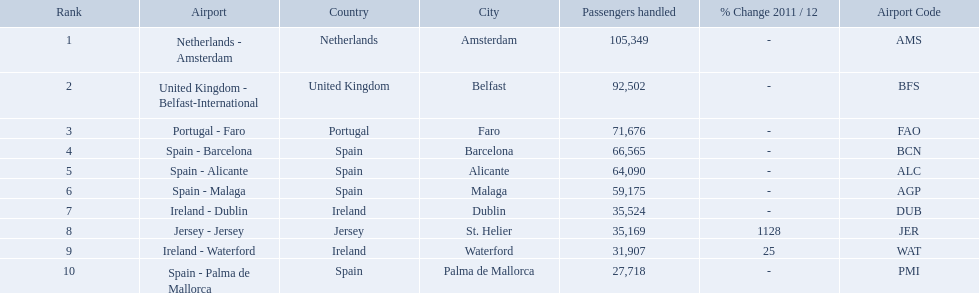Which airports had passengers going through london southend airport? Netherlands - Amsterdam, United Kingdom - Belfast-International, Portugal - Faro, Spain - Barcelona, Spain - Alicante, Spain - Malaga, Ireland - Dublin, Jersey - Jersey, Ireland - Waterford, Spain - Palma de Mallorca. Of those airports, which airport had the least amount of passengers going through london southend airport? Spain - Palma de Mallorca. What are all the passengers handled values for london southend airport? 105,349, 92,502, 71,676, 66,565, 64,090, 59,175, 35,524, 35,169, 31,907, 27,718. Which are 30,000 or less? 27,718. What airport is this for? Spain - Palma de Mallorca. How many passengers did the united kingdom handle? 92,502. Parse the full table. {'header': ['Rank', 'Airport', 'Country', 'City', 'Passengers handled', '% Change 2011 / 12', 'Airport Code'], 'rows': [['1', 'Netherlands - Amsterdam', 'Netherlands', 'Amsterdam', '105,349', '-', 'AMS'], ['2', 'United Kingdom - Belfast-International', 'United Kingdom', 'Belfast', '92,502', '-', 'BFS'], ['3', 'Portugal - Faro', 'Portugal', 'Faro', '71,676', '-', 'FAO'], ['4', 'Spain - Barcelona', 'Spain', 'Barcelona', '66,565', '-', 'BCN'], ['5', 'Spain - Alicante', 'Spain', 'Alicante', '64,090', '-', 'ALC'], ['6', 'Spain - Malaga', 'Spain', 'Malaga', '59,175', '-', 'AGP'], ['7', 'Ireland - Dublin', 'Ireland', 'Dublin', '35,524', '-', 'DUB'], ['8', 'Jersey - Jersey', 'Jersey', 'St. Helier', '35,169', '1128', 'JER'], ['9', 'Ireland - Waterford', 'Ireland', 'Waterford', '31,907', '25', 'WAT'], ['10', 'Spain - Palma de Mallorca', 'Spain', 'Palma de Mallorca', '27,718', '-', 'PMI']]} Who handled more passengers than this? Netherlands - Amsterdam. What are the names of all the airports? Netherlands - Amsterdam, United Kingdom - Belfast-International, Portugal - Faro, Spain - Barcelona, Spain - Alicante, Spain - Malaga, Ireland - Dublin, Jersey - Jersey, Ireland - Waterford, Spain - Palma de Mallorca. Of these, what are all the passenger counts? 105,349, 92,502, 71,676, 66,565, 64,090, 59,175, 35,524, 35,169, 31,907, 27,718. Of these, which airport had more passengers than the united kingdom? Netherlands - Amsterdam. What are all the airports in the top 10 busiest routes to and from london southend airport? Netherlands - Amsterdam, United Kingdom - Belfast-International, Portugal - Faro, Spain - Barcelona, Spain - Alicante, Spain - Malaga, Ireland - Dublin, Jersey - Jersey, Ireland - Waterford, Spain - Palma de Mallorca. Which airports are in portugal? Portugal - Faro. What is the best rank? 1. What is the airport? Netherlands - Amsterdam. What is the highest number of passengers handled? 105,349. What is the destination of the passengers leaving the area that handles 105,349 travellers? Netherlands - Amsterdam. 